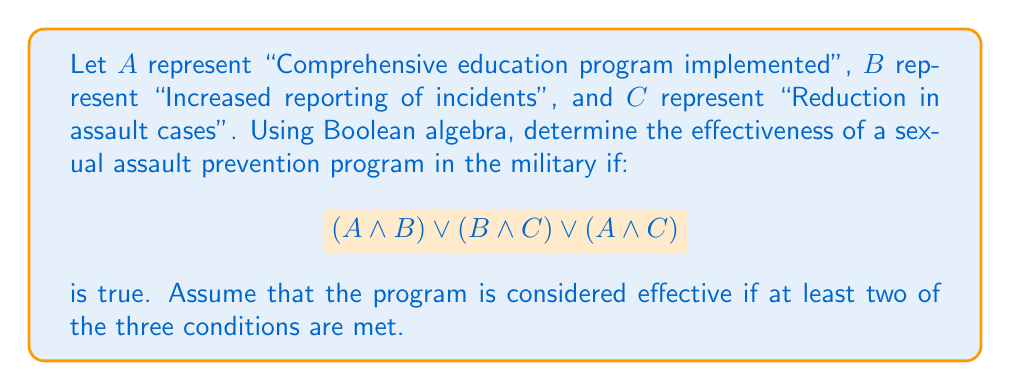Solve this math problem. Let's approach this step-by-step using Boolean algebra:

1) The given expression is in the form of a disjunction (OR) of three conjunctions (ANDs):
   $$(A \land B) \lor (B \land C) \lor (A \land C)$$

2) This expression will be true if at least one of the conjunctions is true.

3) Each conjunction represents two conditions being met:
   - $A \land B$: Education program implemented AND increased reporting
   - $B \land C$: Increased reporting AND reduction in cases
   - $A \land C$: Education program implemented AND reduction in cases

4) For the program to be considered effective, at least two conditions must be met.

5) If any of these conjunctions is true, it means that at least two conditions are met:
   - If $A \land B$ is true, then A and B are both true (2 conditions met)
   - If $B \land C$ is true, then B and C are both true (2 conditions met)
   - If $A \land C$ is true, then A and C are both true (2 conditions met)

6) Therefore, if the given Boolean expression is true, it guarantees that at least two of the three conditions are met.

7) This aligns with our definition of effectiveness for the sexual assault prevention program.

Thus, if the given Boolean expression is true, the program is considered effective.
Answer: Effective 